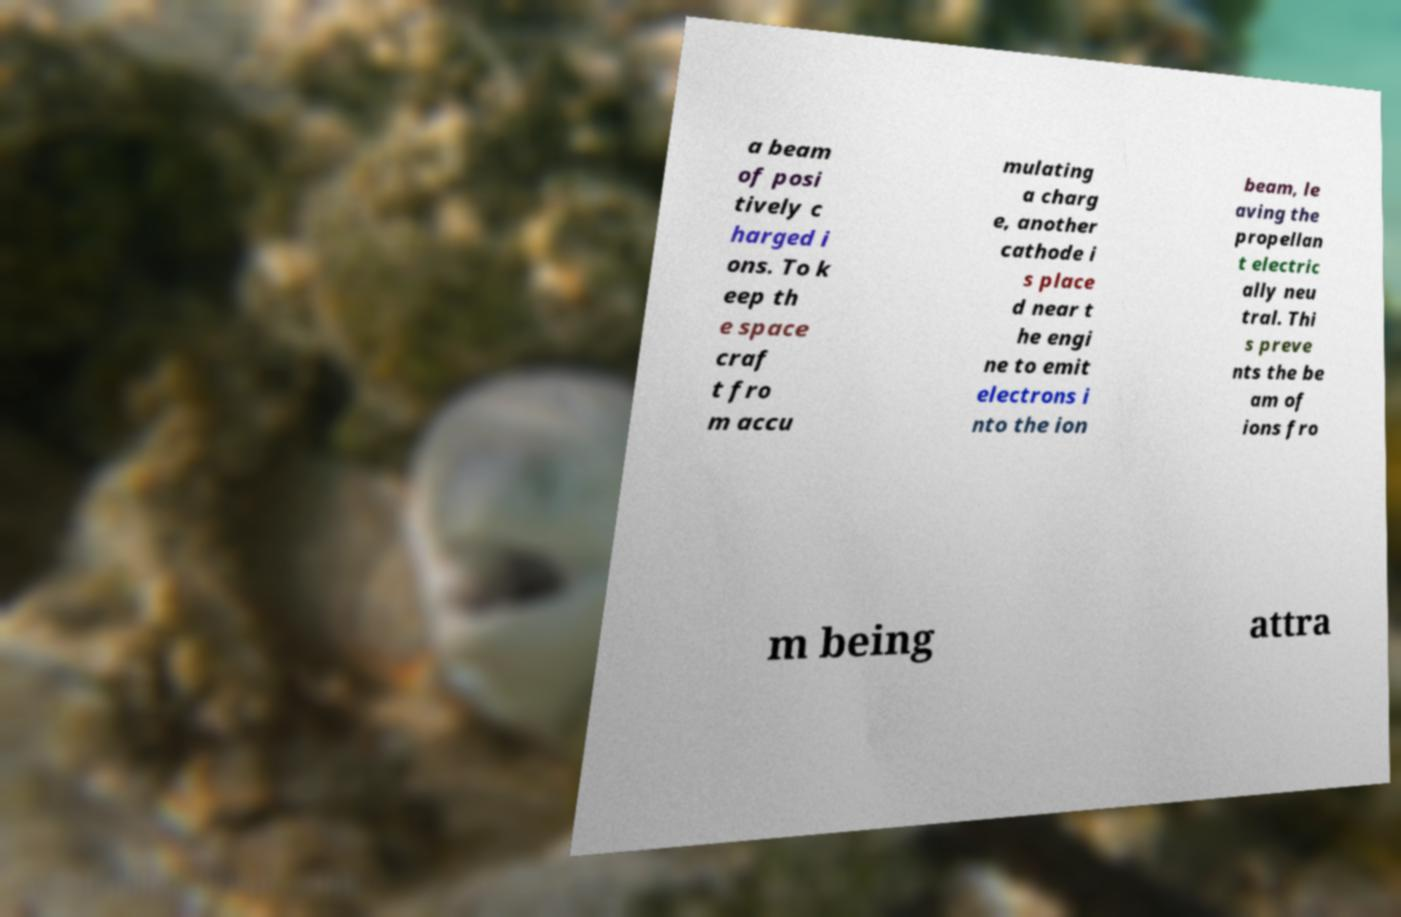For documentation purposes, I need the text within this image transcribed. Could you provide that? a beam of posi tively c harged i ons. To k eep th e space craf t fro m accu mulating a charg e, another cathode i s place d near t he engi ne to emit electrons i nto the ion beam, le aving the propellan t electric ally neu tral. Thi s preve nts the be am of ions fro m being attra 